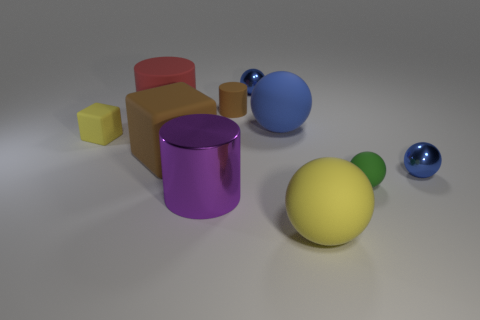Is there anything else that is the same shape as the purple metal thing?
Offer a very short reply. Yes. Does the green sphere have the same material as the red cylinder?
Provide a short and direct response. Yes. There is a metallic sphere that is behind the big blue sphere; are there any metal objects in front of it?
Ensure brevity in your answer.  Yes. How many cylinders are behind the yellow cube and on the right side of the red object?
Your answer should be very brief. 1. What is the shape of the yellow matte thing that is behind the big yellow sphere?
Your answer should be compact. Cube. What number of other metal cylinders have the same size as the brown cylinder?
Give a very brief answer. 0. Do the big ball that is in front of the blue matte sphere and the small cube have the same color?
Give a very brief answer. Yes. What is the thing that is in front of the tiny rubber ball and right of the tiny brown rubber cylinder made of?
Provide a succinct answer. Rubber. Are there more large green matte cubes than large purple cylinders?
Provide a short and direct response. No. What color is the small rubber block to the left of the tiny matte object in front of the metallic ball that is right of the blue matte ball?
Ensure brevity in your answer.  Yellow. 